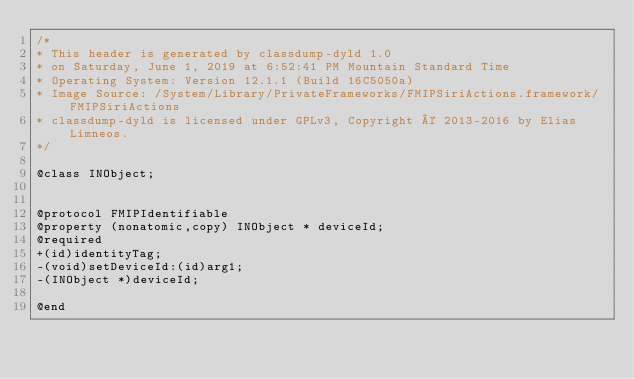Convert code to text. <code><loc_0><loc_0><loc_500><loc_500><_C_>/*
* This header is generated by classdump-dyld 1.0
* on Saturday, June 1, 2019 at 6:52:41 PM Mountain Standard Time
* Operating System: Version 12.1.1 (Build 16C5050a)
* Image Source: /System/Library/PrivateFrameworks/FMIPSiriActions.framework/FMIPSiriActions
* classdump-dyld is licensed under GPLv3, Copyright © 2013-2016 by Elias Limneos.
*/

@class INObject;


@protocol FMIPIdentifiable
@property (nonatomic,copy) INObject * deviceId; 
@required
+(id)identityTag;
-(void)setDeviceId:(id)arg1;
-(INObject *)deviceId;

@end

</code> 